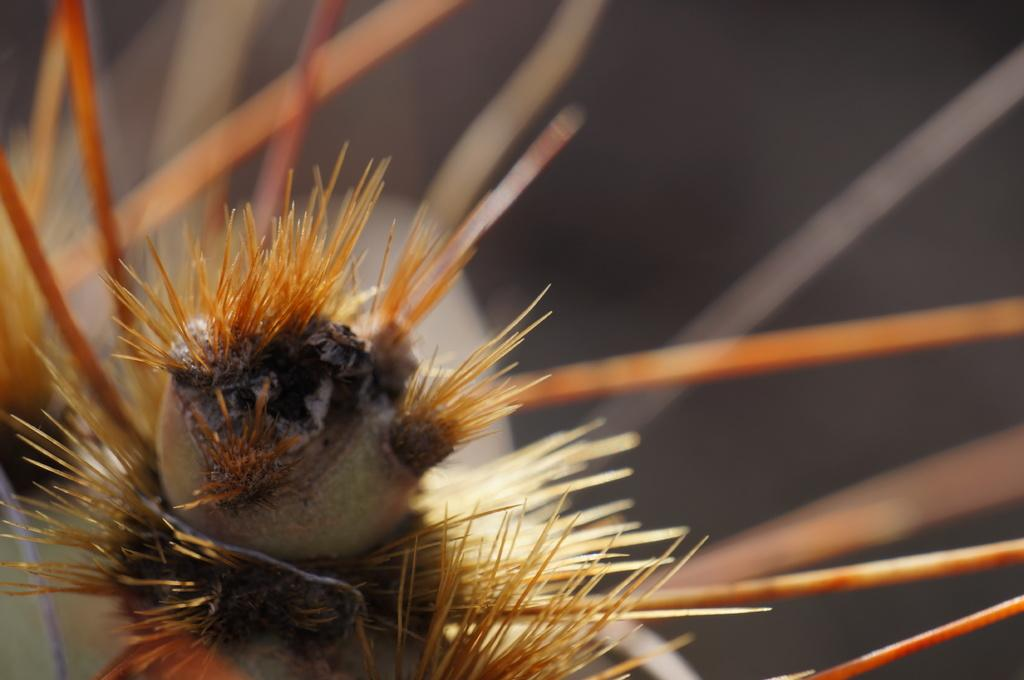What is the main subject of the image? The main subject of the image is a spiky plant-like object. How close is the camera to the spiky object in the image? The image is a macro photography of the spiky object, which means the camera is very close to it. What can be observed about the background of the image? The background of the image is blurred. What type of bait is being used to attract the spiky object in the image? There is no bait present in the image, as it is a photograph of a spiky plant-like object. Can you tell me how many tents are set up in the camp near the spiky object in the image? There is no camp or tents present in the image; it is a close-up photograph of a spiky plant-like object. 